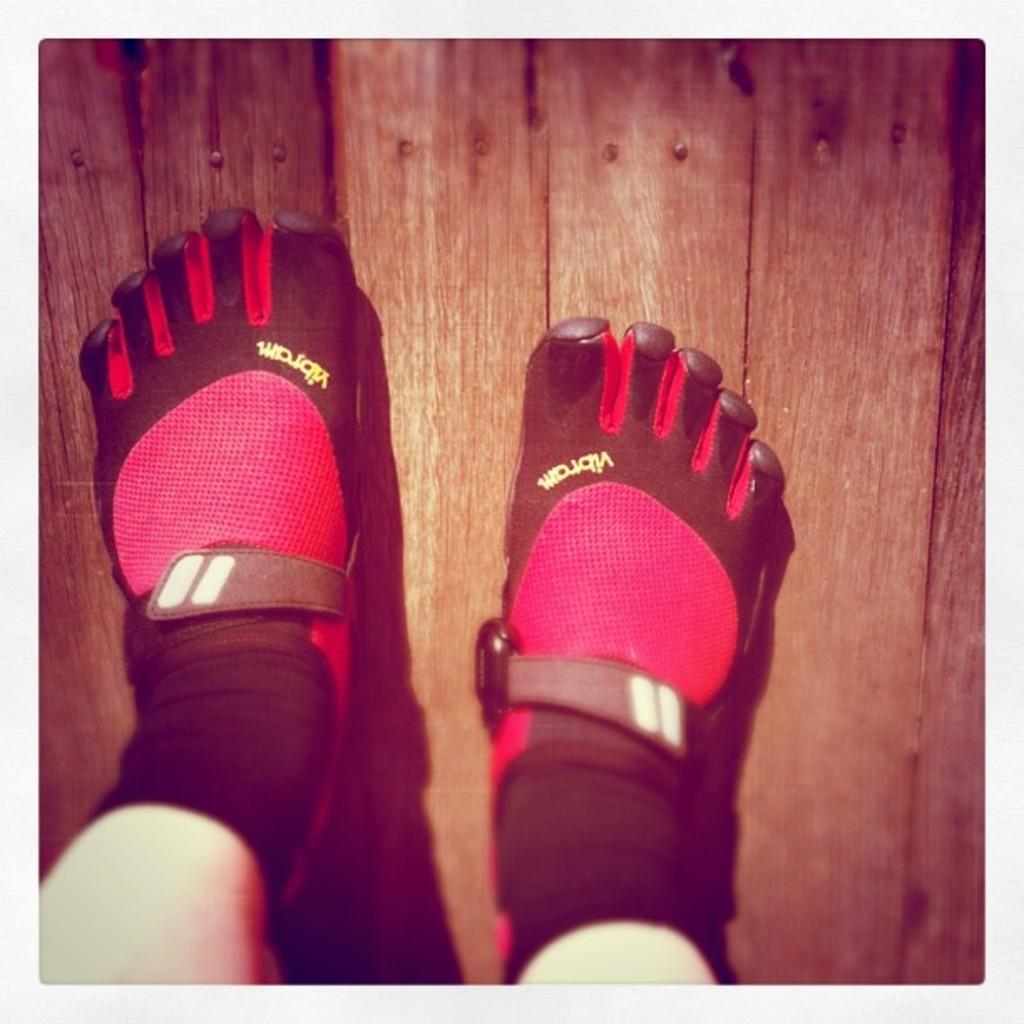What body part is visible in the image? There is a person's legs in the image. What are the person's legs wearing? The person's legs are wearing socks. What type of surface is the person standing on? The person is standing on a wooden surface. What rule or authority is depicted in the image? There is no rule or authority depicted in the image; it only shows a person's legs wearing socks and standing on a wooden surface. 